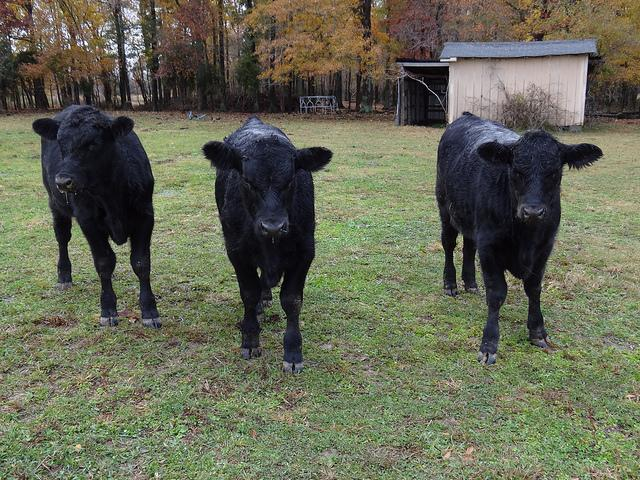How many cows are standing in the pasture field? Please explain your reasoning. three. There are more than two but less than four cows. 